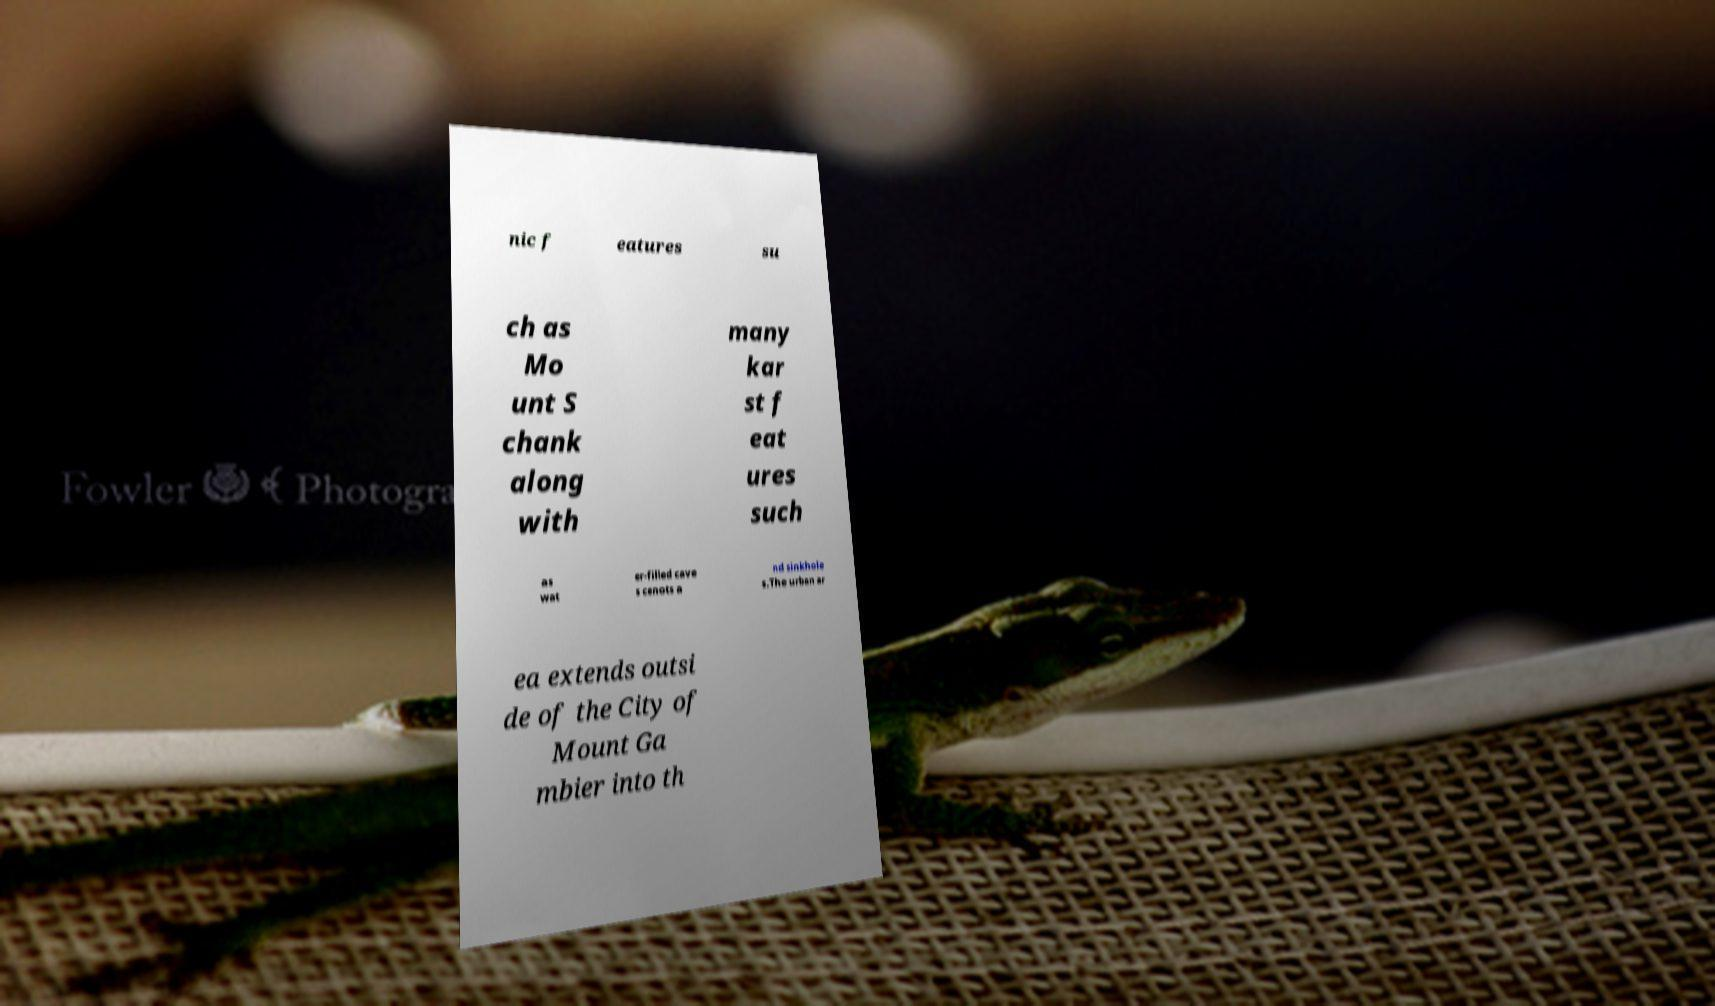Could you extract and type out the text from this image? nic f eatures su ch as Mo unt S chank along with many kar st f eat ures such as wat er-filled cave s cenots a nd sinkhole s.The urban ar ea extends outsi de of the City of Mount Ga mbier into th 